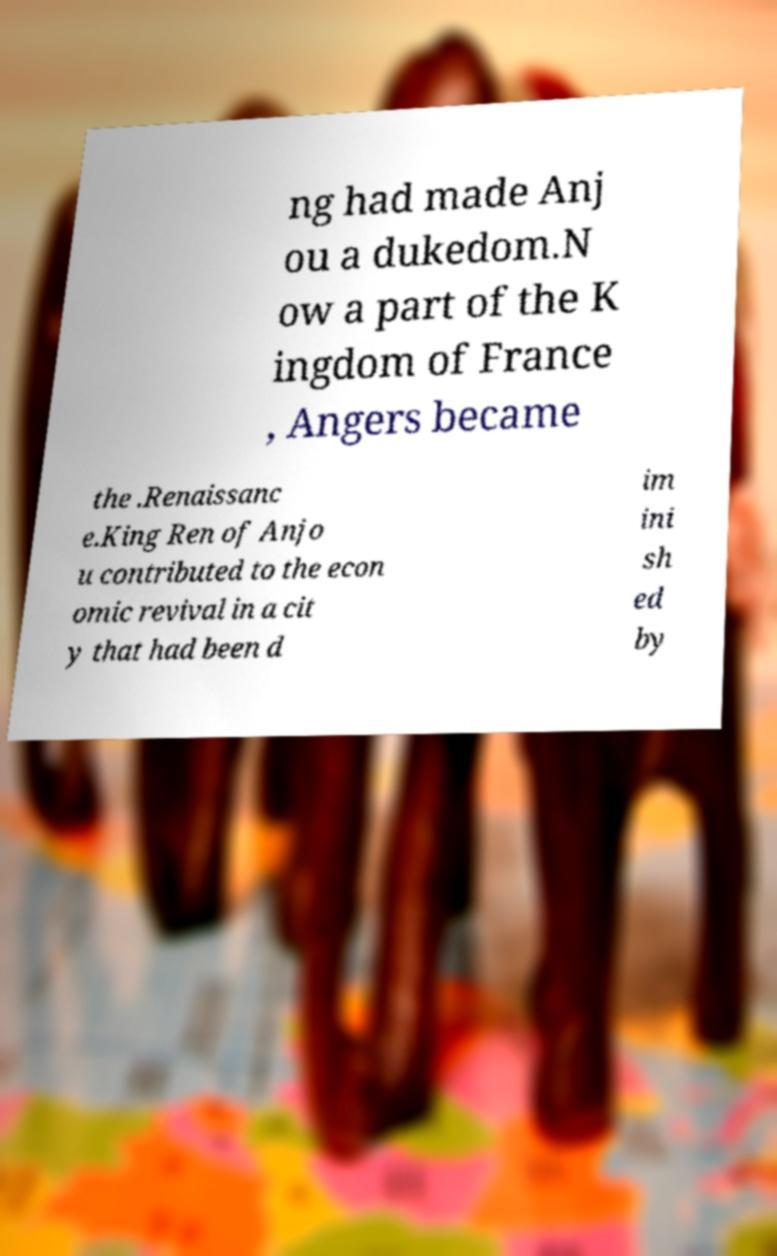For documentation purposes, I need the text within this image transcribed. Could you provide that? ng had made Anj ou a dukedom.N ow a part of the K ingdom of France , Angers became the .Renaissanc e.King Ren of Anjo u contributed to the econ omic revival in a cit y that had been d im ini sh ed by 